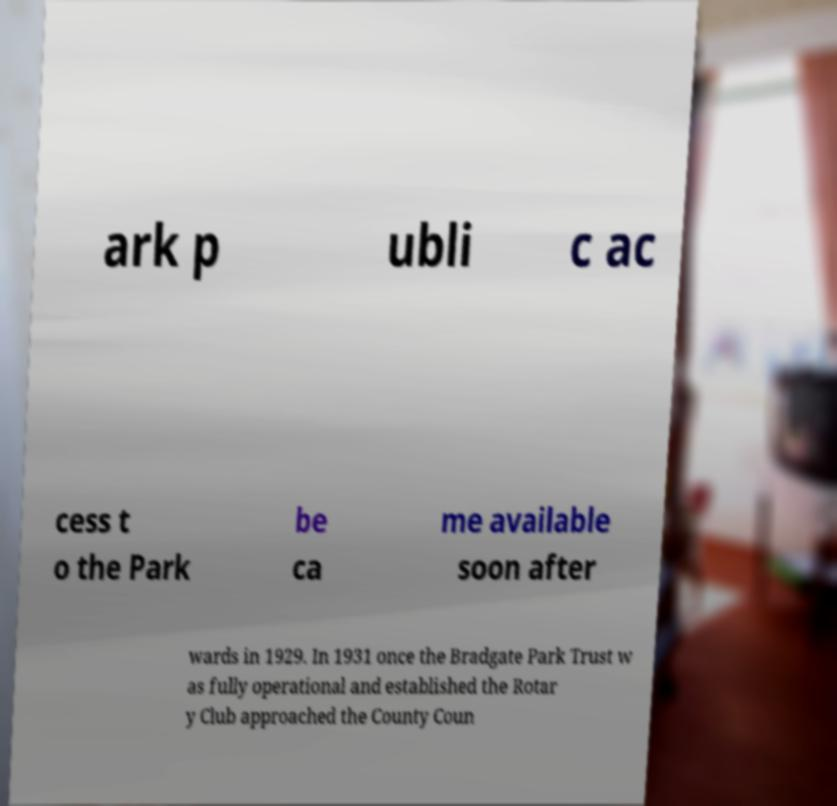What messages or text are displayed in this image? I need them in a readable, typed format. ark p ubli c ac cess t o the Park be ca me available soon after wards in 1929. In 1931 once the Bradgate Park Trust w as fully operational and established the Rotar y Club approached the County Coun 